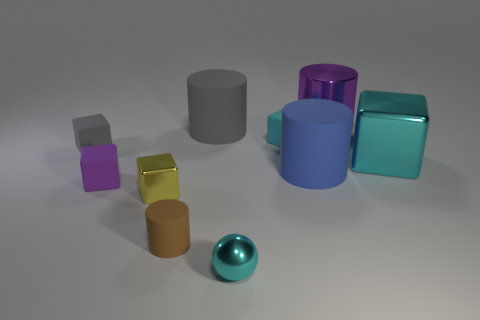Is there any other thing that has the same color as the large metal cylinder?
Provide a succinct answer. Yes. There is a purple object that is made of the same material as the cyan ball; what is its shape?
Provide a short and direct response. Cylinder. What is the material of the thing that is in front of the matte thing in front of the small purple rubber block?
Your answer should be very brief. Metal. Does the large object that is right of the large purple metal cylinder have the same shape as the large gray rubber object?
Provide a succinct answer. No. Is the number of purple rubber objects that are to the right of the large gray rubber thing greater than the number of small blue metal spheres?
Offer a terse response. No. Is there any other thing that has the same material as the big gray cylinder?
Ensure brevity in your answer.  Yes. There is a thing that is the same color as the big metallic cylinder; what is its shape?
Your response must be concise. Cube. What number of blocks are tiny rubber objects or big things?
Your answer should be very brief. 4. What is the color of the large cylinder that is on the left side of the cyan cube to the left of the big purple metallic cylinder?
Keep it short and to the point. Gray. Is the color of the large shiny block the same as the metallic cube that is on the left side of the purple cylinder?
Make the answer very short. No. 